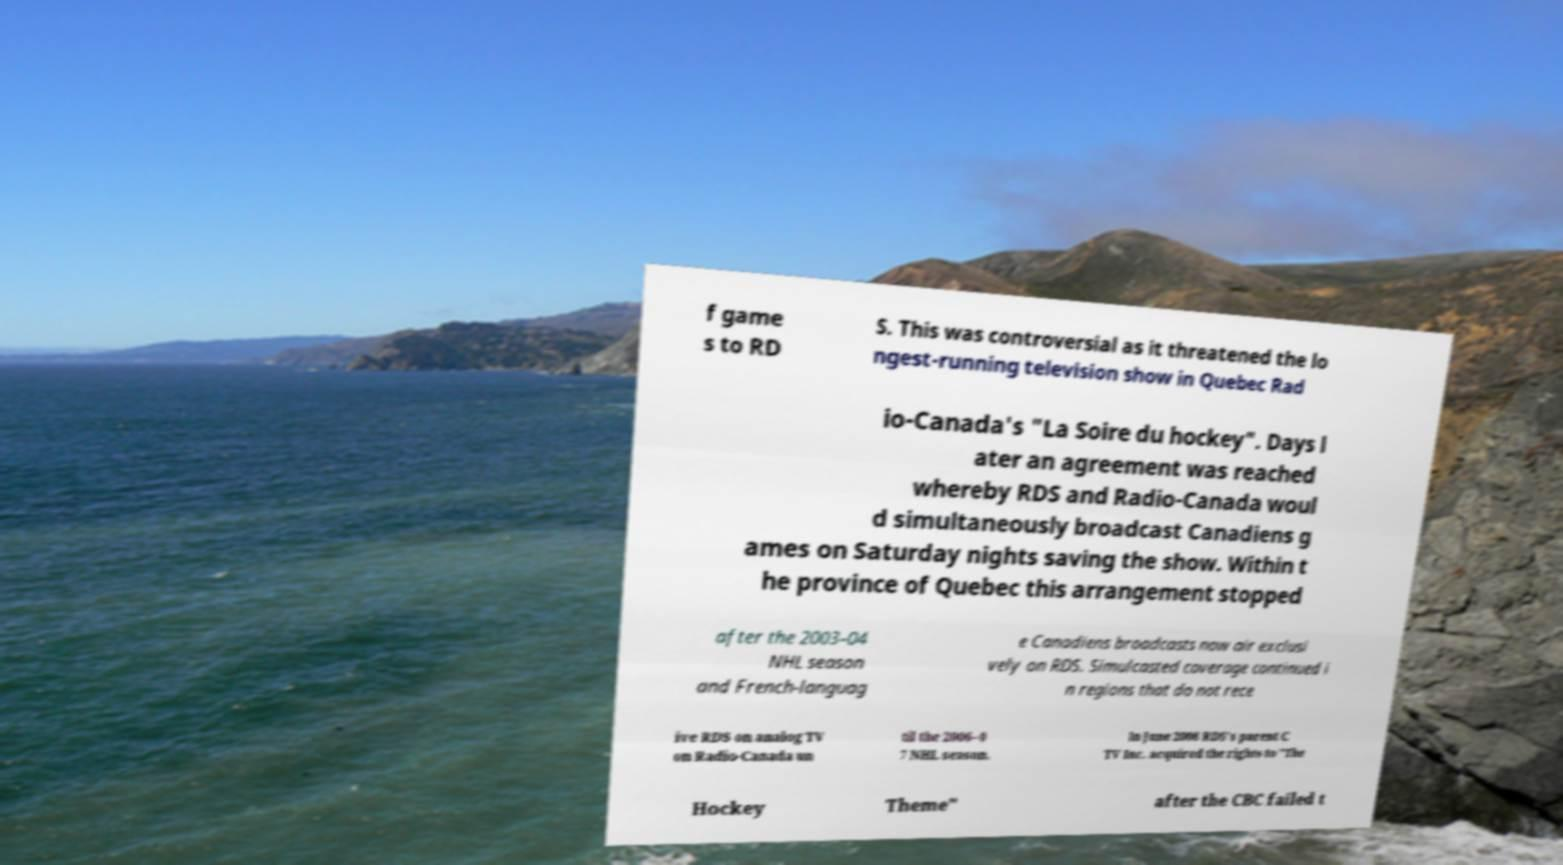Could you extract and type out the text from this image? f game s to RD S. This was controversial as it threatened the lo ngest-running television show in Quebec Rad io-Canada's "La Soire du hockey". Days l ater an agreement was reached whereby RDS and Radio-Canada woul d simultaneously broadcast Canadiens g ames on Saturday nights saving the show. Within t he province of Quebec this arrangement stopped after the 2003–04 NHL season and French-languag e Canadiens broadcasts now air exclusi vely on RDS. Simulcasted coverage continued i n regions that do not rece ive RDS on analog TV on Radio-Canada un til the 2006–0 7 NHL season. In June 2008 RDS's parent C TV Inc. acquired the rights to "The Hockey Theme" after the CBC failed t 